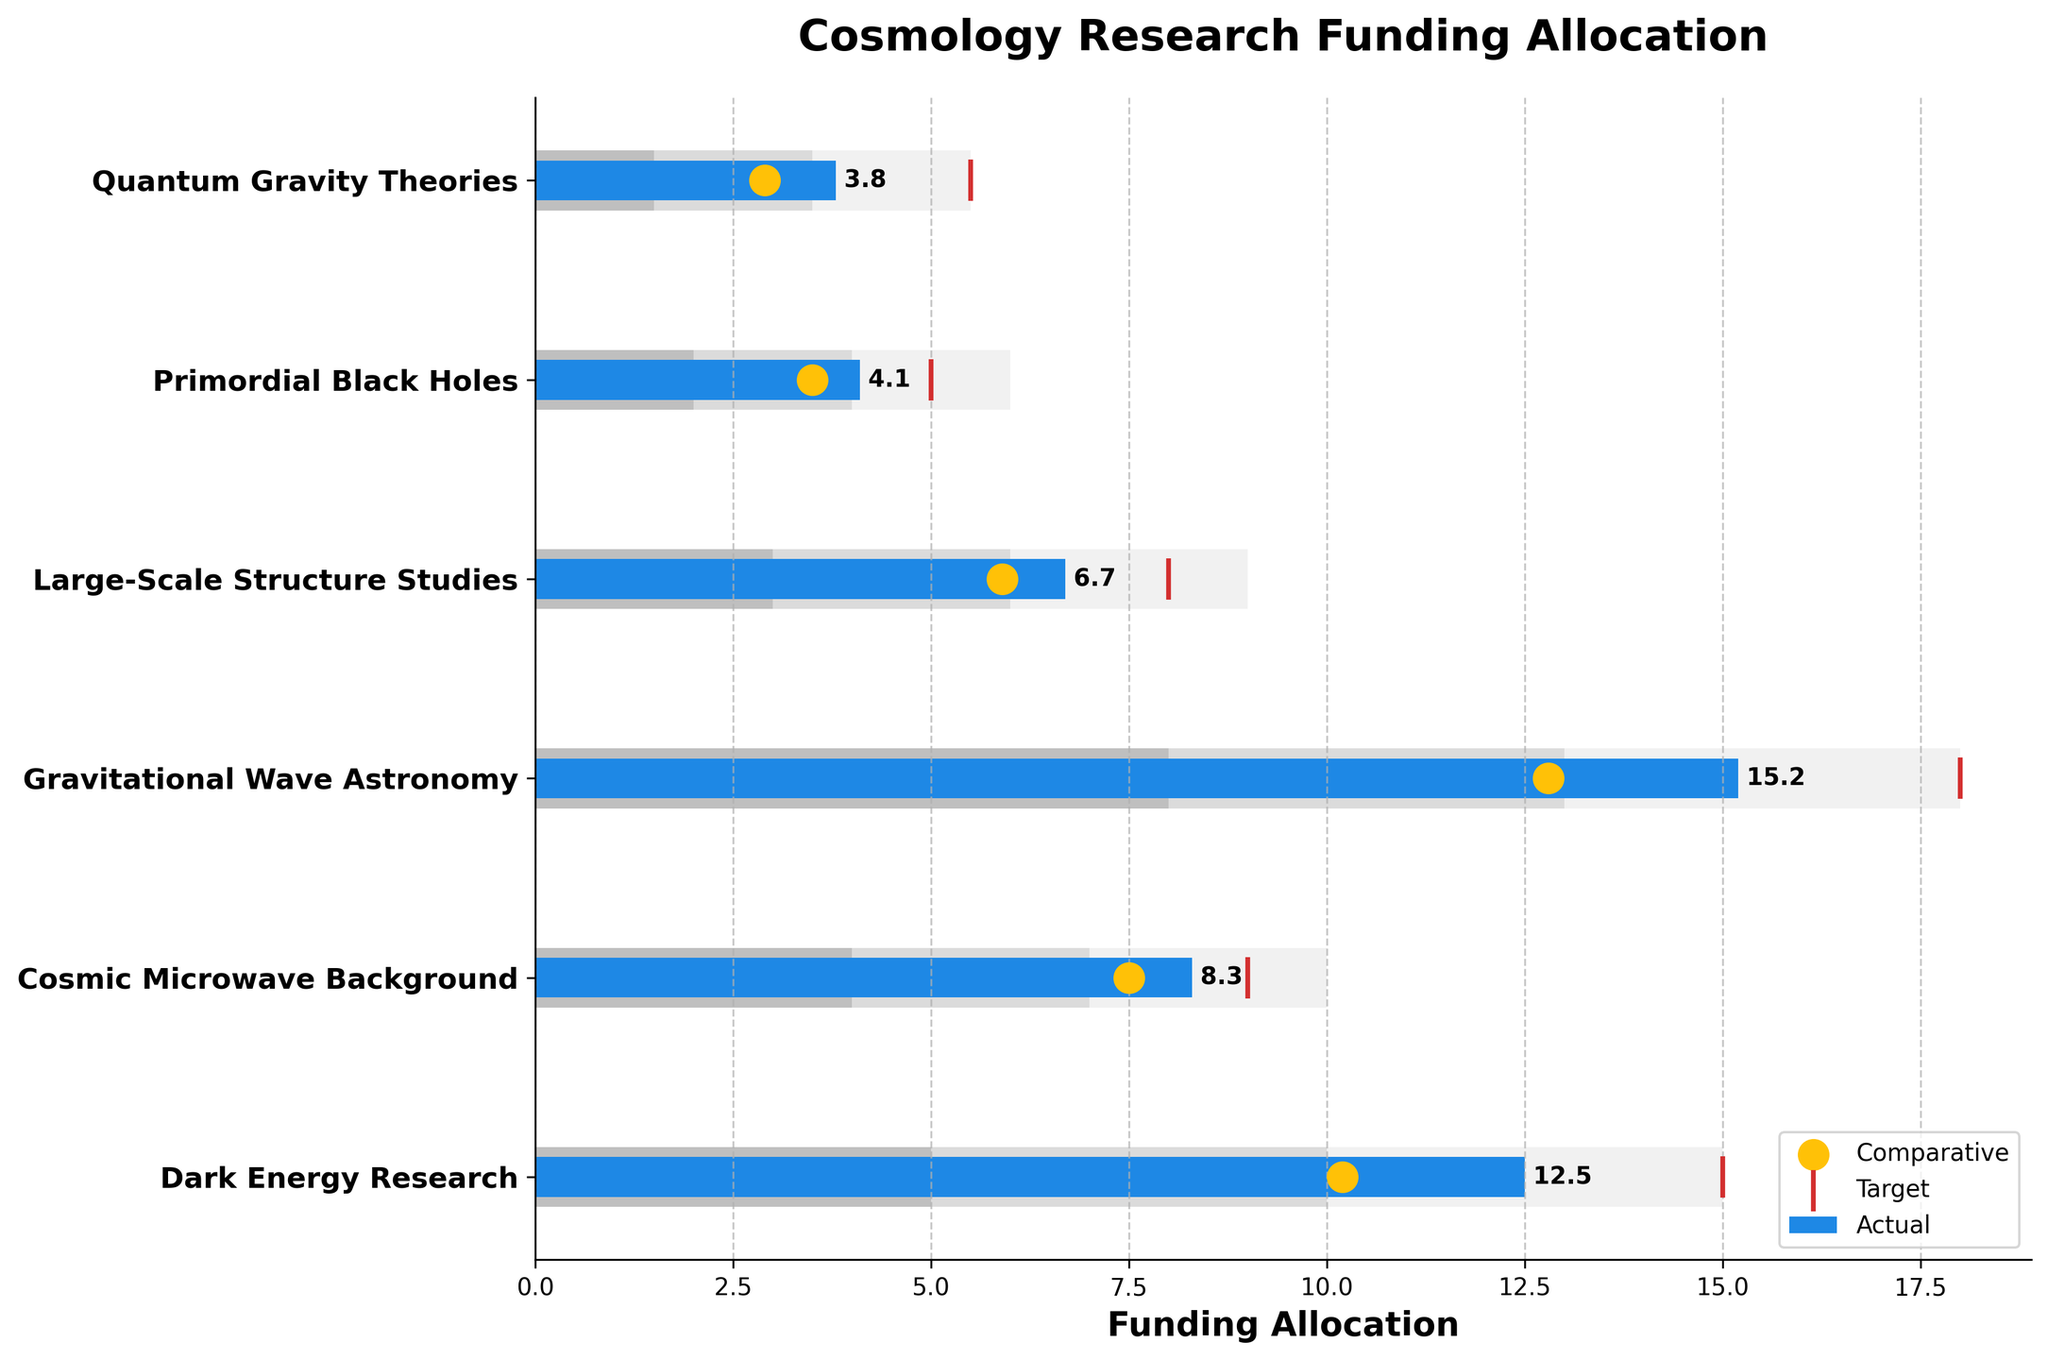What is the title of the chart? The title is written at the top of the chart. The title is "Cosmology Research Funding Allocation."
Answer: Cosmology Research Funding Allocation Which category has the highest actual funding allocation? By observing the blue bars representing the actual values, we can see that "Gravitational Wave Astronomy" has the longest blue bar.
Answer: Gravitational Wave Astronomy What is the comparative value for Dark Energy Research? The comparative values are represented by the yellow dots. For "Dark Energy Research," the yellow dot is placed at 10.2 on the x-axis.
Answer: 10.2 How does the actual funding for Large-Scale Structure Studies compare to its target funding? The actual funding (blue bar) for Large-Scale Structure Studies is 6.7. The target funding (red line) is positioned at 8.0. Therefore, the actual funding is less than the target funding.
Answer: Less than What's the difference between the actual and target funding allocation for Quantum Gravity Theories? The actual funding for Quantum Gravity Theories is 3.8, and its target funding is 5.5. The difference is calculated as 5.5 - 3.8.
Answer: 1.7 Which categories meet or exceed their target funding allocation? We observe that the "Gravitational Wave Astronomy" has a blue bar extending approximately to the same length as the red line at 18.0, indicating it meets the target. "Dark Energy Research" actual bar is also very close to the target but is not above. Thus, only "Gravitational Wave Astronomy" meets its target.
Answer: Gravitational Wave Astronomy In which category does the actual funding allocation surpass the comparative value the most? By comparing the blue bars (actual) to the yellow dots (comparative), "Gravitational Wave Astronomy" shows the largest visual difference where the actual (15.2) substantially exceeds the comparative (12.8).
Answer: Gravitational Wave Astronomy What range does Large-Scale Structure Studies fall into? The actual value for Large-Scale Structure Studies is 6.7. It falls between the second and third range colored bands, which are marked at 6.0 and 9.0. So, it falls within the middle range.
Answer: Middle range (between 6.0 and 9.0) How many categories have actual funding lower than their comparative values? By comparing the blue bars (actual) with the yellow dots (comparative), "Primordial Black Holes" (4.1 vs. 3.5) and "Quantum Gravity Theories" (3.8 vs. 2.9) are the only categories where the actual funding is higher than the comparative value. Therefore, other categories have actual funding lower than comparative values.
Answer: 4 categories 